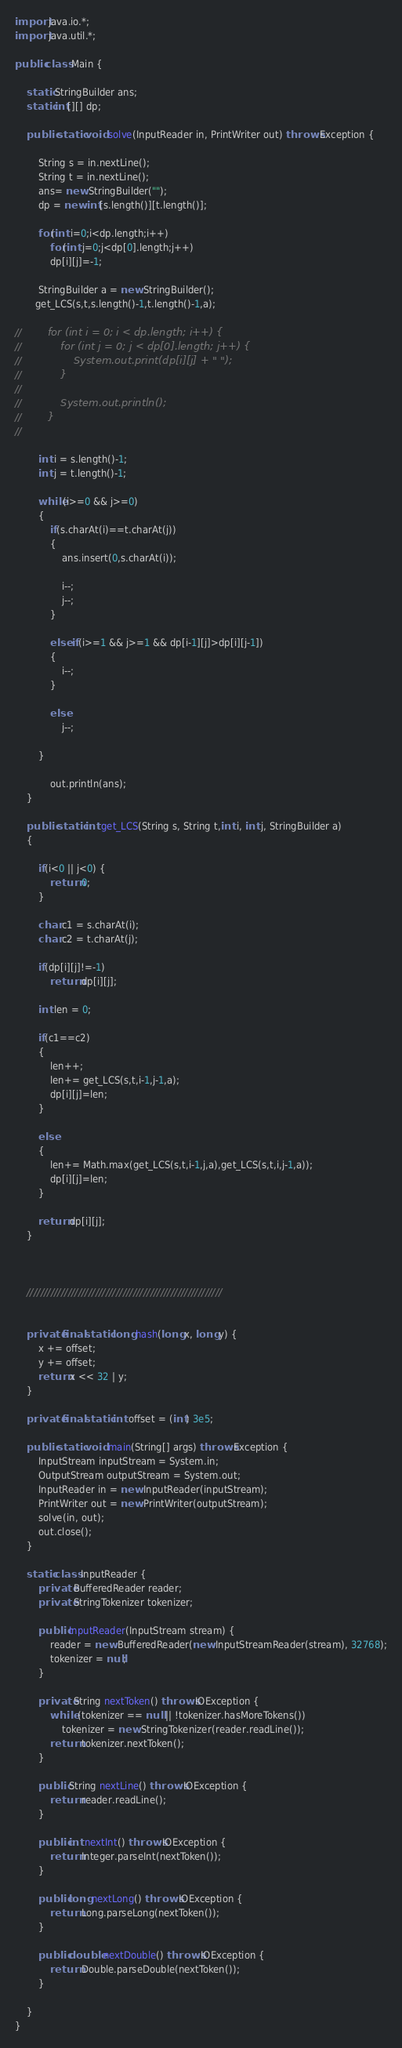<code> <loc_0><loc_0><loc_500><loc_500><_Java_>import java.io.*;
import java.util.*;

public class Main {

    static StringBuilder ans;
    static int[][] dp;

    public static void solve(InputReader in, PrintWriter out) throws Exception {

        String s = in.nextLine();
        String t = in.nextLine();
        ans= new StringBuilder("");
        dp = new int[s.length()][t.length()];

        for(int i=0;i<dp.length;i++)
            for(int j=0;j<dp[0].length;j++)
            dp[i][j]=-1;

        StringBuilder a = new StringBuilder();
       get_LCS(s,t,s.length()-1,t.length()-1,a);

//        for (int i = 0; i < dp.length; i++) {
//            for (int j = 0; j < dp[0].length; j++) {
//                System.out.print(dp[i][j] + " ");
//            }
//
//            System.out.println();
//        }
//

        int i = s.length()-1;
        int j = t.length()-1;

        while(i>=0 && j>=0)
        {
            if(s.charAt(i)==t.charAt(j))
            {
                ans.insert(0,s.charAt(i));

                i--;
                j--;
            }

            else if(i>=1 && j>=1 && dp[i-1][j]>dp[i][j-1])
            {
                i--;
            }

            else
                j--;

        }

            out.println(ans);
    }

    public static int get_LCS(String s, String t,int i, int j, StringBuilder a)
    {

        if(i<0 || j<0) {
            return 0;
        }

        char c1 = s.charAt(i);
        char c2 = t.charAt(j);

        if(dp[i][j]!=-1)
            return dp[i][j];

        int len = 0;

        if(c1==c2)
        {
            len++;
            len+= get_LCS(s,t,i-1,j-1,a);
            dp[i][j]=len;
        }

        else
        {
            len+= Math.max(get_LCS(s,t,i-1,j,a),get_LCS(s,t,i,j-1,a));
            dp[i][j]=len;
        }

        return dp[i][j];
    }



    /////////////////////////////////////////////////////////


    private final static long hash(long x, long y) {
        x += offset;
        y += offset;
        return x << 32 | y;
    }

    private final static int offset = (int) 3e5;

    public static void main(String[] args) throws Exception {
        InputStream inputStream = System.in;
        OutputStream outputStream = System.out;
        InputReader in = new InputReader(inputStream);
        PrintWriter out = new PrintWriter(outputStream);
        solve(in, out);
        out.close();
    }

    static class InputReader {
        private BufferedReader reader;
        private StringTokenizer tokenizer;

        public InputReader(InputStream stream) {
            reader = new BufferedReader(new InputStreamReader(stream), 32768);
            tokenizer = null;
        }

        private String nextToken() throws IOException {
            while (tokenizer == null || !tokenizer.hasMoreTokens())
                tokenizer = new StringTokenizer(reader.readLine());
            return tokenizer.nextToken();
        }

        public String nextLine() throws IOException {
            return reader.readLine();
        }

        public int nextInt() throws IOException {
            return Integer.parseInt(nextToken());
        }

        public long nextLong() throws IOException {
            return Long.parseLong(nextToken());
        }

        public double nextDouble() throws IOException {
            return Double.parseDouble(nextToken());
        }

    }
}
</code> 